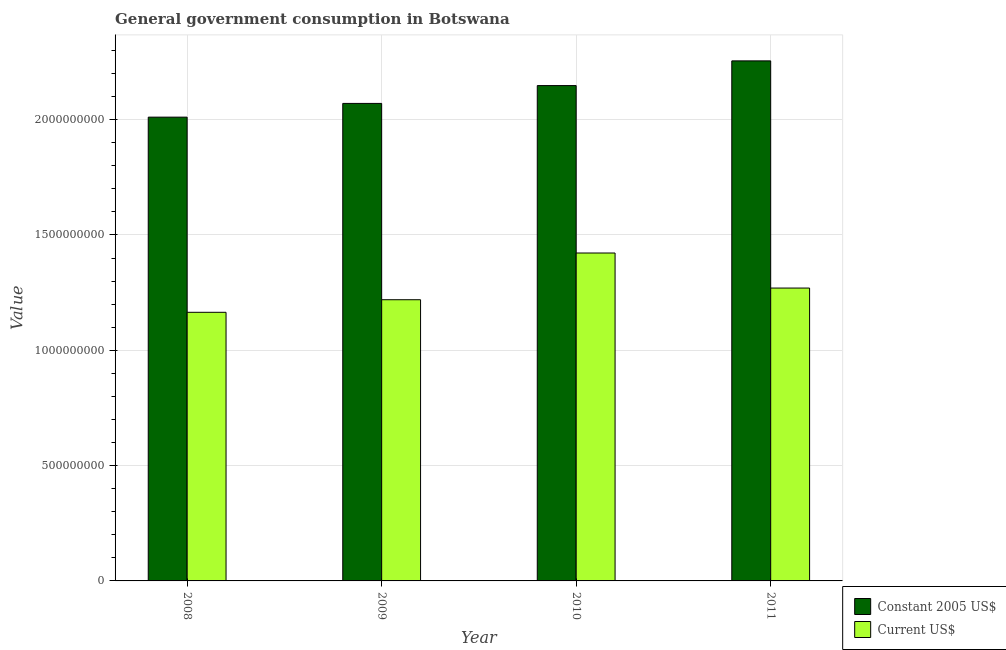How many different coloured bars are there?
Make the answer very short. 2. How many groups of bars are there?
Your answer should be very brief. 4. Are the number of bars per tick equal to the number of legend labels?
Offer a very short reply. Yes. Are the number of bars on each tick of the X-axis equal?
Ensure brevity in your answer.  Yes. How many bars are there on the 4th tick from the left?
Ensure brevity in your answer.  2. How many bars are there on the 2nd tick from the right?
Your response must be concise. 2. What is the label of the 2nd group of bars from the left?
Your response must be concise. 2009. What is the value consumed in constant 2005 us$ in 2008?
Your answer should be compact. 2.01e+09. Across all years, what is the maximum value consumed in constant 2005 us$?
Offer a very short reply. 2.25e+09. Across all years, what is the minimum value consumed in current us$?
Your answer should be very brief. 1.16e+09. In which year was the value consumed in current us$ minimum?
Provide a short and direct response. 2008. What is the total value consumed in constant 2005 us$ in the graph?
Offer a terse response. 8.48e+09. What is the difference between the value consumed in constant 2005 us$ in 2008 and that in 2009?
Provide a succinct answer. -5.96e+07. What is the difference between the value consumed in constant 2005 us$ in 2008 and the value consumed in current us$ in 2009?
Offer a terse response. -5.96e+07. What is the average value consumed in constant 2005 us$ per year?
Provide a short and direct response. 2.12e+09. What is the ratio of the value consumed in constant 2005 us$ in 2010 to that in 2011?
Offer a terse response. 0.95. Is the value consumed in constant 2005 us$ in 2008 less than that in 2011?
Ensure brevity in your answer.  Yes. What is the difference between the highest and the second highest value consumed in current us$?
Offer a very short reply. 1.52e+08. What is the difference between the highest and the lowest value consumed in constant 2005 us$?
Your answer should be compact. 2.44e+08. Is the sum of the value consumed in current us$ in 2009 and 2011 greater than the maximum value consumed in constant 2005 us$ across all years?
Provide a short and direct response. Yes. What does the 1st bar from the left in 2009 represents?
Offer a very short reply. Constant 2005 US$. What does the 1st bar from the right in 2011 represents?
Ensure brevity in your answer.  Current US$. How many bars are there?
Ensure brevity in your answer.  8. Does the graph contain grids?
Keep it short and to the point. Yes. Where does the legend appear in the graph?
Keep it short and to the point. Bottom right. What is the title of the graph?
Provide a succinct answer. General government consumption in Botswana. What is the label or title of the X-axis?
Provide a short and direct response. Year. What is the label or title of the Y-axis?
Give a very brief answer. Value. What is the Value in Constant 2005 US$ in 2008?
Offer a very short reply. 2.01e+09. What is the Value in Current US$ in 2008?
Give a very brief answer. 1.16e+09. What is the Value of Constant 2005 US$ in 2009?
Your answer should be compact. 2.07e+09. What is the Value of Current US$ in 2009?
Your answer should be compact. 1.22e+09. What is the Value of Constant 2005 US$ in 2010?
Make the answer very short. 2.15e+09. What is the Value in Current US$ in 2010?
Your response must be concise. 1.42e+09. What is the Value in Constant 2005 US$ in 2011?
Ensure brevity in your answer.  2.25e+09. What is the Value of Current US$ in 2011?
Your answer should be compact. 1.27e+09. Across all years, what is the maximum Value of Constant 2005 US$?
Your response must be concise. 2.25e+09. Across all years, what is the maximum Value in Current US$?
Make the answer very short. 1.42e+09. Across all years, what is the minimum Value in Constant 2005 US$?
Ensure brevity in your answer.  2.01e+09. Across all years, what is the minimum Value in Current US$?
Your answer should be compact. 1.16e+09. What is the total Value of Constant 2005 US$ in the graph?
Give a very brief answer. 8.48e+09. What is the total Value of Current US$ in the graph?
Your answer should be compact. 5.08e+09. What is the difference between the Value in Constant 2005 US$ in 2008 and that in 2009?
Ensure brevity in your answer.  -5.96e+07. What is the difference between the Value in Current US$ in 2008 and that in 2009?
Offer a terse response. -5.45e+07. What is the difference between the Value of Constant 2005 US$ in 2008 and that in 2010?
Your answer should be compact. -1.37e+08. What is the difference between the Value in Current US$ in 2008 and that in 2010?
Give a very brief answer. -2.57e+08. What is the difference between the Value in Constant 2005 US$ in 2008 and that in 2011?
Your answer should be compact. -2.44e+08. What is the difference between the Value of Current US$ in 2008 and that in 2011?
Keep it short and to the point. -1.05e+08. What is the difference between the Value of Constant 2005 US$ in 2009 and that in 2010?
Offer a terse response. -7.73e+07. What is the difference between the Value in Current US$ in 2009 and that in 2010?
Provide a short and direct response. -2.03e+08. What is the difference between the Value of Constant 2005 US$ in 2009 and that in 2011?
Ensure brevity in your answer.  -1.84e+08. What is the difference between the Value in Current US$ in 2009 and that in 2011?
Give a very brief answer. -5.06e+07. What is the difference between the Value in Constant 2005 US$ in 2010 and that in 2011?
Give a very brief answer. -1.07e+08. What is the difference between the Value in Current US$ in 2010 and that in 2011?
Your answer should be very brief. 1.52e+08. What is the difference between the Value in Constant 2005 US$ in 2008 and the Value in Current US$ in 2009?
Your response must be concise. 7.92e+08. What is the difference between the Value in Constant 2005 US$ in 2008 and the Value in Current US$ in 2010?
Your response must be concise. 5.89e+08. What is the difference between the Value in Constant 2005 US$ in 2008 and the Value in Current US$ in 2011?
Offer a terse response. 7.41e+08. What is the difference between the Value in Constant 2005 US$ in 2009 and the Value in Current US$ in 2010?
Keep it short and to the point. 6.49e+08. What is the difference between the Value in Constant 2005 US$ in 2009 and the Value in Current US$ in 2011?
Offer a terse response. 8.01e+08. What is the difference between the Value in Constant 2005 US$ in 2010 and the Value in Current US$ in 2011?
Provide a short and direct response. 8.78e+08. What is the average Value of Constant 2005 US$ per year?
Your answer should be very brief. 2.12e+09. What is the average Value of Current US$ per year?
Provide a succinct answer. 1.27e+09. In the year 2008, what is the difference between the Value in Constant 2005 US$ and Value in Current US$?
Ensure brevity in your answer.  8.46e+08. In the year 2009, what is the difference between the Value in Constant 2005 US$ and Value in Current US$?
Provide a short and direct response. 8.51e+08. In the year 2010, what is the difference between the Value of Constant 2005 US$ and Value of Current US$?
Your answer should be compact. 7.26e+08. In the year 2011, what is the difference between the Value in Constant 2005 US$ and Value in Current US$?
Keep it short and to the point. 9.85e+08. What is the ratio of the Value of Constant 2005 US$ in 2008 to that in 2009?
Provide a short and direct response. 0.97. What is the ratio of the Value in Current US$ in 2008 to that in 2009?
Make the answer very short. 0.96. What is the ratio of the Value in Constant 2005 US$ in 2008 to that in 2010?
Offer a terse response. 0.94. What is the ratio of the Value of Current US$ in 2008 to that in 2010?
Ensure brevity in your answer.  0.82. What is the ratio of the Value of Constant 2005 US$ in 2008 to that in 2011?
Keep it short and to the point. 0.89. What is the ratio of the Value of Current US$ in 2008 to that in 2011?
Provide a short and direct response. 0.92. What is the ratio of the Value in Constant 2005 US$ in 2009 to that in 2010?
Make the answer very short. 0.96. What is the ratio of the Value of Current US$ in 2009 to that in 2010?
Provide a succinct answer. 0.86. What is the ratio of the Value in Constant 2005 US$ in 2009 to that in 2011?
Your response must be concise. 0.92. What is the ratio of the Value of Current US$ in 2009 to that in 2011?
Your answer should be compact. 0.96. What is the ratio of the Value of Constant 2005 US$ in 2010 to that in 2011?
Your answer should be compact. 0.95. What is the ratio of the Value of Current US$ in 2010 to that in 2011?
Give a very brief answer. 1.12. What is the difference between the highest and the second highest Value of Constant 2005 US$?
Give a very brief answer. 1.07e+08. What is the difference between the highest and the second highest Value in Current US$?
Offer a terse response. 1.52e+08. What is the difference between the highest and the lowest Value of Constant 2005 US$?
Give a very brief answer. 2.44e+08. What is the difference between the highest and the lowest Value of Current US$?
Ensure brevity in your answer.  2.57e+08. 